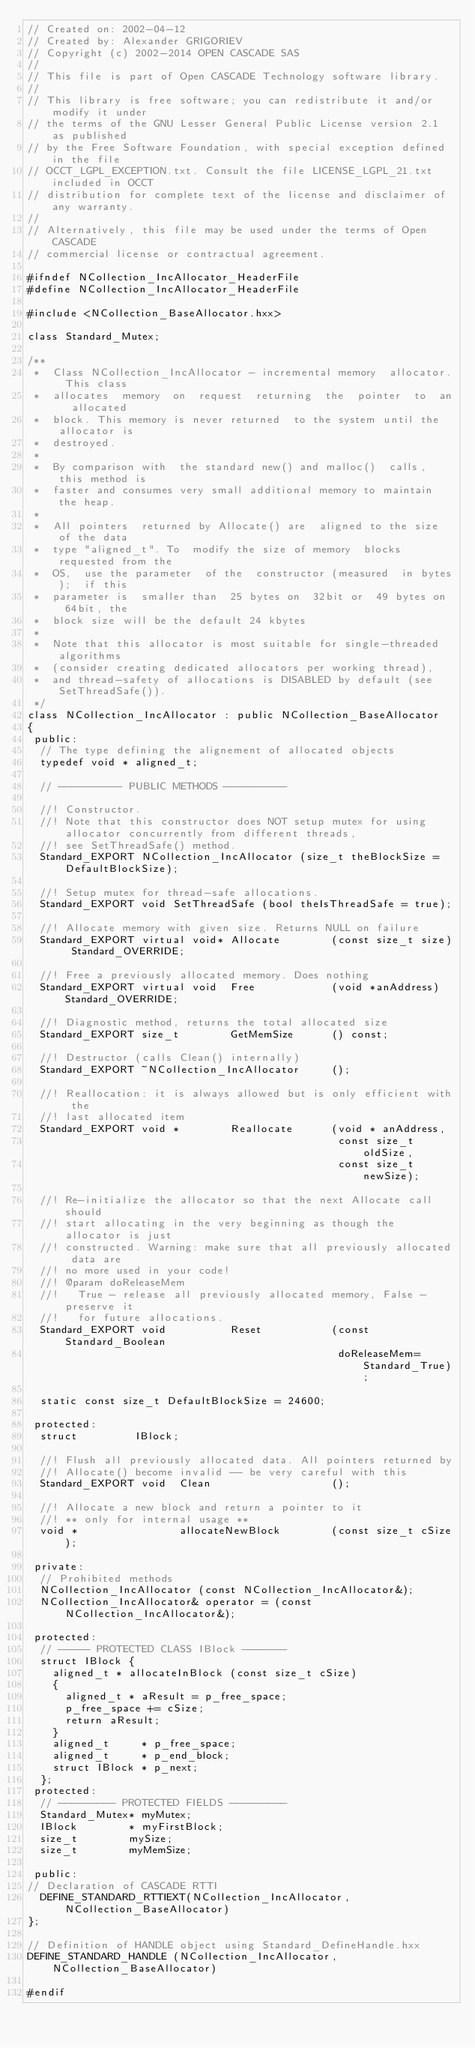<code> <loc_0><loc_0><loc_500><loc_500><_C++_>// Created on: 2002-04-12
// Created by: Alexander GRIGORIEV
// Copyright (c) 2002-2014 OPEN CASCADE SAS
//
// This file is part of Open CASCADE Technology software library.
//
// This library is free software; you can redistribute it and/or modify it under
// the terms of the GNU Lesser General Public License version 2.1 as published
// by the Free Software Foundation, with special exception defined in the file
// OCCT_LGPL_EXCEPTION.txt. Consult the file LICENSE_LGPL_21.txt included in OCCT
// distribution for complete text of the license and disclaimer of any warranty.
//
// Alternatively, this file may be used under the terms of Open CASCADE
// commercial license or contractual agreement.

#ifndef NCollection_IncAllocator_HeaderFile
#define NCollection_IncAllocator_HeaderFile

#include <NCollection_BaseAllocator.hxx>

class Standard_Mutex;

/**
 *  Class NCollection_IncAllocator - incremental memory  allocator. This class
 *  allocates  memory  on  request  returning  the  pointer  to  an  allocated
 *  block. This memory is never returned  to the system until the allocator is
 *  destroyed.
 *
 *  By comparison with  the standard new() and malloc()  calls, this method is
 *  faster and consumes very small additional memory to maintain the heap.
 *
 *  All pointers  returned by Allocate() are  aligned to the size  of the data
 *  type "aligned_t". To  modify the size of memory  blocks requested from the
 *  OS,  use the parameter  of the  constructor (measured  in bytes);  if this
 *  parameter is  smaller than  25 bytes on  32bit or  49 bytes on  64bit, the
 *  block size will be the default 24 kbytes
 *
 *  Note that this allocator is most suitable for single-threaded algorithms
 *  (consider creating dedicated allocators per working thread),
 *  and thread-safety of allocations is DISABLED by default (see SetThreadSafe()).
 */
class NCollection_IncAllocator : public NCollection_BaseAllocator
{
 public:
  // The type defining the alignement of allocated objects
  typedef void * aligned_t;

  // ---------- PUBLIC METHODS ----------

  //! Constructor.
  //! Note that this constructor does NOT setup mutex for using allocator concurrently from different threads,
  //! see SetThreadSafe() method.
  Standard_EXPORT NCollection_IncAllocator (size_t theBlockSize = DefaultBlockSize);

  //! Setup mutex for thread-safe allocations.
  Standard_EXPORT void SetThreadSafe (bool theIsThreadSafe = true);

  //! Allocate memory with given size. Returns NULL on failure
  Standard_EXPORT virtual void* Allocate        (const size_t size) Standard_OVERRIDE;

  //! Free a previously allocated memory. Does nothing
  Standard_EXPORT virtual void  Free            (void *anAddress) Standard_OVERRIDE;

  //! Diagnostic method, returns the total allocated size
  Standard_EXPORT size_t        GetMemSize      () const;

  //! Destructor (calls Clean() internally)
  Standard_EXPORT ~NCollection_IncAllocator     ();

  //! Reallocation: it is always allowed but is only efficient with the
  //! last allocated item
  Standard_EXPORT void *        Reallocate      (void * anAddress,
                                                 const size_t oldSize,
                                                 const size_t newSize);

  //! Re-initialize the allocator so that the next Allocate call should
  //! start allocating in the very beginning as though the allocator is just
  //! constructed. Warning: make sure that all previously allocated data are
  //! no more used in your code!
  //! @param doReleaseMem
  //!   True - release all previously allocated memory, False - preserve it
  //!   for future allocations.
  Standard_EXPORT void          Reset           (const Standard_Boolean
                                                 doReleaseMem=Standard_True);

  static const size_t DefaultBlockSize = 24600;

 protected:
  struct         IBlock;

  //! Flush all previously allocated data. All pointers returned by
  //! Allocate() become invalid -- be very careful with this
  Standard_EXPORT void  Clean                   ();

  //! Allocate a new block and return a pointer to it
  //! ** only for internal usage **
  void *                allocateNewBlock        (const size_t cSize);

 private:
  // Prohibited methods
  NCollection_IncAllocator (const NCollection_IncAllocator&);
  NCollection_IncAllocator& operator = (const NCollection_IncAllocator&);

 protected:
  // ----- PROTECTED CLASS IBlock -------
  struct IBlock {
    aligned_t * allocateInBlock (const size_t cSize)
    {
      aligned_t * aResult = p_free_space;
      p_free_space += cSize;
      return aResult;
    }
    aligned_t     * p_free_space;
    aligned_t     * p_end_block;
    struct IBlock * p_next;
  };
 protected:
  // --------- PROTECTED FIELDS ---------
  Standard_Mutex* myMutex;
  IBlock        * myFirstBlock;
  size_t        mySize;
  size_t        myMemSize;

 public:
// Declaration of CASCADE RTTI
  DEFINE_STANDARD_RTTIEXT(NCollection_IncAllocator,NCollection_BaseAllocator)
};

// Definition of HANDLE object using Standard_DefineHandle.hxx
DEFINE_STANDARD_HANDLE (NCollection_IncAllocator, NCollection_BaseAllocator)

#endif
</code> 